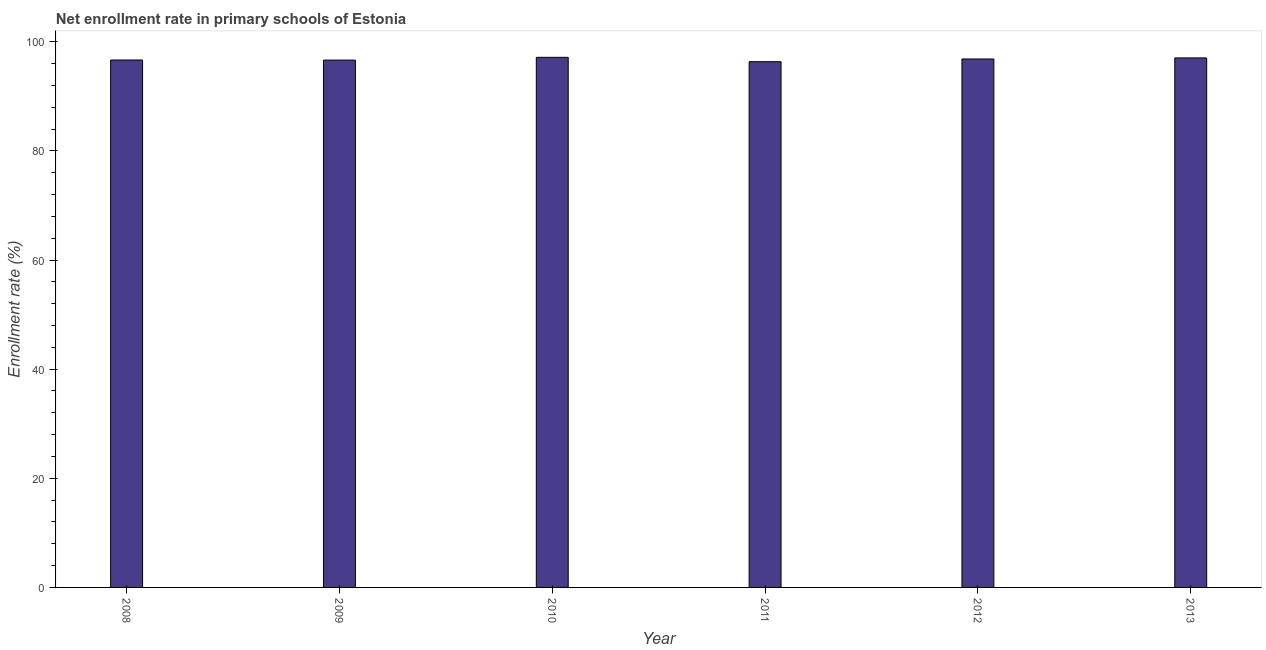Does the graph contain any zero values?
Provide a succinct answer. No. Does the graph contain grids?
Make the answer very short. No. What is the title of the graph?
Make the answer very short. Net enrollment rate in primary schools of Estonia. What is the label or title of the Y-axis?
Keep it short and to the point. Enrollment rate (%). What is the net enrollment rate in primary schools in 2011?
Offer a terse response. 96.35. Across all years, what is the maximum net enrollment rate in primary schools?
Your response must be concise. 97.15. Across all years, what is the minimum net enrollment rate in primary schools?
Your answer should be very brief. 96.35. In which year was the net enrollment rate in primary schools maximum?
Your answer should be very brief. 2010. In which year was the net enrollment rate in primary schools minimum?
Offer a terse response. 2011. What is the sum of the net enrollment rate in primary schools?
Your answer should be very brief. 580.69. What is the difference between the net enrollment rate in primary schools in 2010 and 2011?
Your answer should be very brief. 0.8. What is the average net enrollment rate in primary schools per year?
Give a very brief answer. 96.78. What is the median net enrollment rate in primary schools?
Make the answer very short. 96.75. What is the ratio of the net enrollment rate in primary schools in 2008 to that in 2013?
Give a very brief answer. 1. Is the difference between the net enrollment rate in primary schools in 2009 and 2012 greater than the difference between any two years?
Give a very brief answer. No. What is the difference between the highest and the second highest net enrollment rate in primary schools?
Your answer should be compact. 0.11. Is the sum of the net enrollment rate in primary schools in 2008 and 2010 greater than the maximum net enrollment rate in primary schools across all years?
Offer a terse response. Yes. Are the values on the major ticks of Y-axis written in scientific E-notation?
Keep it short and to the point. No. What is the Enrollment rate (%) of 2008?
Ensure brevity in your answer.  96.66. What is the Enrollment rate (%) of 2009?
Offer a terse response. 96.64. What is the Enrollment rate (%) of 2010?
Offer a very short reply. 97.15. What is the Enrollment rate (%) in 2011?
Your answer should be very brief. 96.35. What is the Enrollment rate (%) of 2012?
Ensure brevity in your answer.  96.85. What is the Enrollment rate (%) of 2013?
Offer a very short reply. 97.04. What is the difference between the Enrollment rate (%) in 2008 and 2009?
Your response must be concise. 0.02. What is the difference between the Enrollment rate (%) in 2008 and 2010?
Provide a short and direct response. -0.49. What is the difference between the Enrollment rate (%) in 2008 and 2011?
Your response must be concise. 0.31. What is the difference between the Enrollment rate (%) in 2008 and 2012?
Ensure brevity in your answer.  -0.19. What is the difference between the Enrollment rate (%) in 2008 and 2013?
Make the answer very short. -0.38. What is the difference between the Enrollment rate (%) in 2009 and 2010?
Provide a succinct answer. -0.51. What is the difference between the Enrollment rate (%) in 2009 and 2011?
Offer a terse response. 0.29. What is the difference between the Enrollment rate (%) in 2009 and 2012?
Keep it short and to the point. -0.21. What is the difference between the Enrollment rate (%) in 2009 and 2013?
Provide a short and direct response. -0.4. What is the difference between the Enrollment rate (%) in 2010 and 2011?
Offer a terse response. 0.8. What is the difference between the Enrollment rate (%) in 2010 and 2012?
Your answer should be compact. 0.3. What is the difference between the Enrollment rate (%) in 2010 and 2013?
Offer a very short reply. 0.11. What is the difference between the Enrollment rate (%) in 2011 and 2012?
Provide a succinct answer. -0.5. What is the difference between the Enrollment rate (%) in 2011 and 2013?
Provide a succinct answer. -0.69. What is the difference between the Enrollment rate (%) in 2012 and 2013?
Offer a very short reply. -0.19. What is the ratio of the Enrollment rate (%) in 2008 to that in 2009?
Ensure brevity in your answer.  1. What is the ratio of the Enrollment rate (%) in 2008 to that in 2010?
Ensure brevity in your answer.  0.99. What is the ratio of the Enrollment rate (%) in 2008 to that in 2011?
Your response must be concise. 1. What is the ratio of the Enrollment rate (%) in 2008 to that in 2012?
Offer a very short reply. 1. What is the ratio of the Enrollment rate (%) in 2008 to that in 2013?
Your answer should be very brief. 1. What is the ratio of the Enrollment rate (%) in 2009 to that in 2010?
Give a very brief answer. 0.99. What is the ratio of the Enrollment rate (%) in 2009 to that in 2012?
Give a very brief answer. 1. What is the ratio of the Enrollment rate (%) in 2009 to that in 2013?
Provide a succinct answer. 1. What is the ratio of the Enrollment rate (%) in 2010 to that in 2013?
Offer a very short reply. 1. What is the ratio of the Enrollment rate (%) in 2011 to that in 2012?
Keep it short and to the point. 0.99. What is the ratio of the Enrollment rate (%) in 2011 to that in 2013?
Keep it short and to the point. 0.99. What is the ratio of the Enrollment rate (%) in 2012 to that in 2013?
Ensure brevity in your answer.  1. 